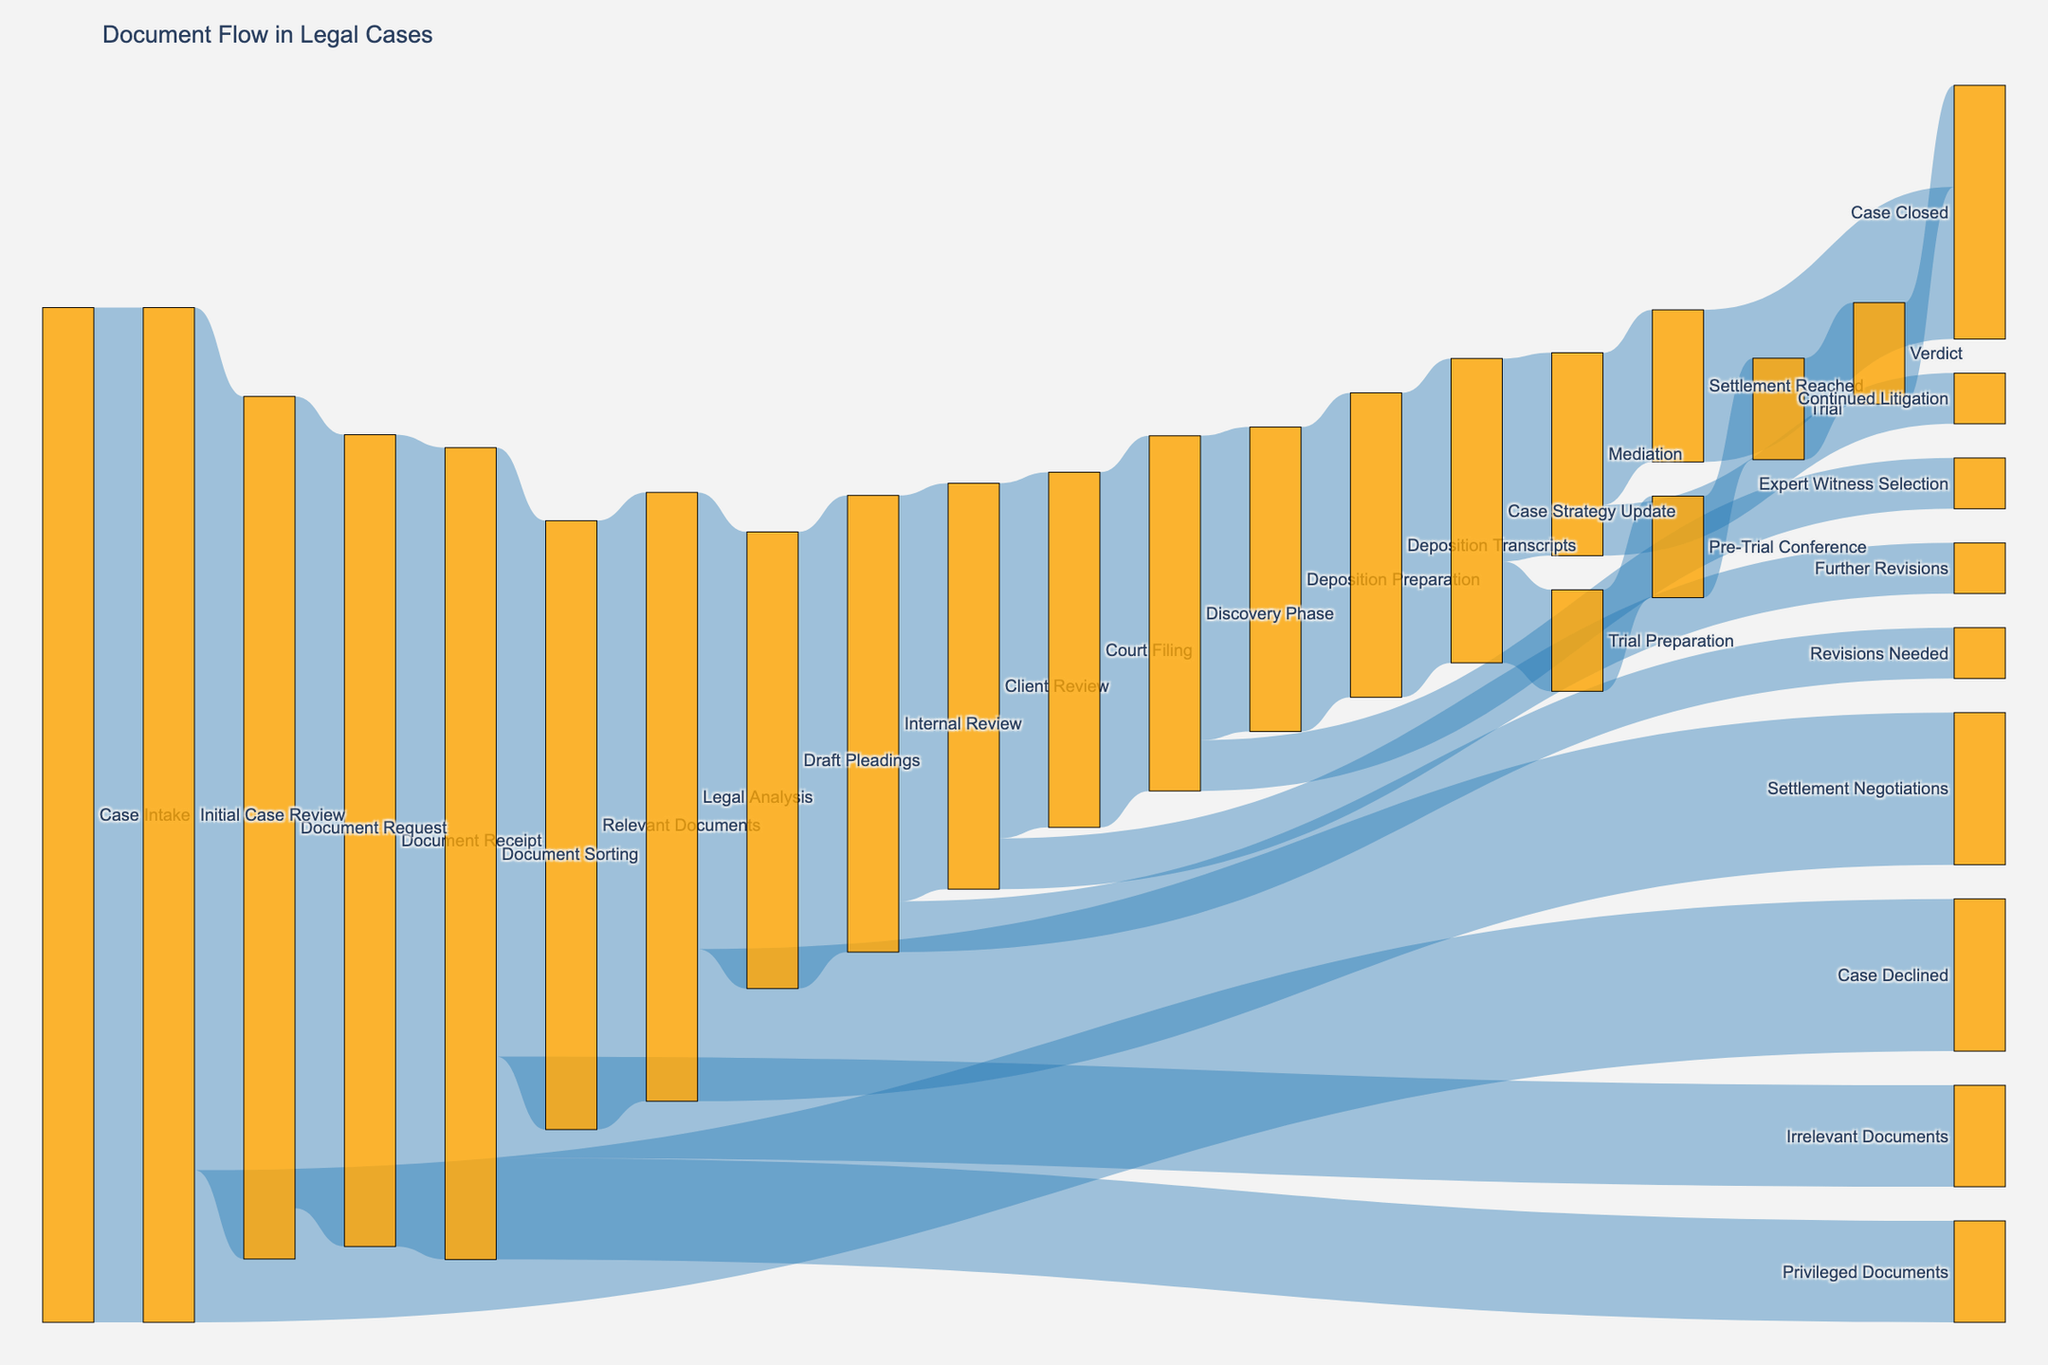How many cases reached the Discovery Phase? By following the flow, we see "Court Filing" leads to the "Discovery Phase" with a value of 35.
Answer: 35 What is the sum of the cases that resulted in Settlement Reached and Verdict? The Sankey diagram shows "Settlement Reached" with 15 cases and "Verdict" with 10 cases. Summing these values gives us 15 + 10.
Answer: 25 How many cases proceed from the Initial Case Review to Document Request? The link from "Initial Case Review" to "Document Request" shows a value of 85.
Answer: 85 Which phase has the highest number of cases rerouted to Revisions Needed and Further Revisions combined? "Internal Review" reroutes to "Revisions Needed" with 5 cases and "Client Review" reroutes to "Further Revisions" with 5 cases. Both sums amount to 10 cases each, but "Client Review" has 40 cases proceeding to "Court Filing", evaluating it further supports this phase.
Answer: Client Review Which stage follows Deposition Preparation in the document flow? According to the diagram, "Deposition Preparation" leads to "Deposition Transcripts".
Answer: Deposition Transcripts What is the number of cases declined at Initial Case Review? The value provided in the diagram for "Initial Case Review" to "Case Declined" is 15.
Answer: 15 Compare the number of cases between Document Sorting's Relevant Documents and Irrelevant Documents. "Relevant Documents" from "Document Sorting" shows 60 cases, while "Irrelevant Documents" shows 10 cases.
Answer: Relevant Documents > Irrelevant Documents How many documents were reviewed in the Client Review stage but were not filed to the court? "Client Review" leads to "Further Revisions" with a value of 5.
Answer: 5 Of the cases entering Settlement Negotiations, what percentage of total reviewed documents does this represent? "Legal Analysis" leads to "Settlement Negotiations" with a value of 15. The total entering "Legal Analysis" is 60. The percentage is (15/60)*100 = 25%.
Answer: 25% Does more case flow into Mediation or Trial Preparation after Case Strategy Update? "Case Strategy Update" leads to "Mediation" with 20 cases and "Trial Preparation" with 10.
Answer: Mediation 